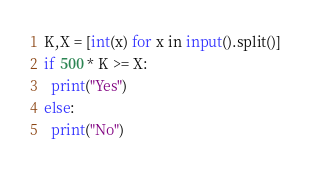<code> <loc_0><loc_0><loc_500><loc_500><_Python_>K,X = [int(x) for x in input().split()]
if 500 * K >= X:
  print("Yes")
else:
  print("No")</code> 